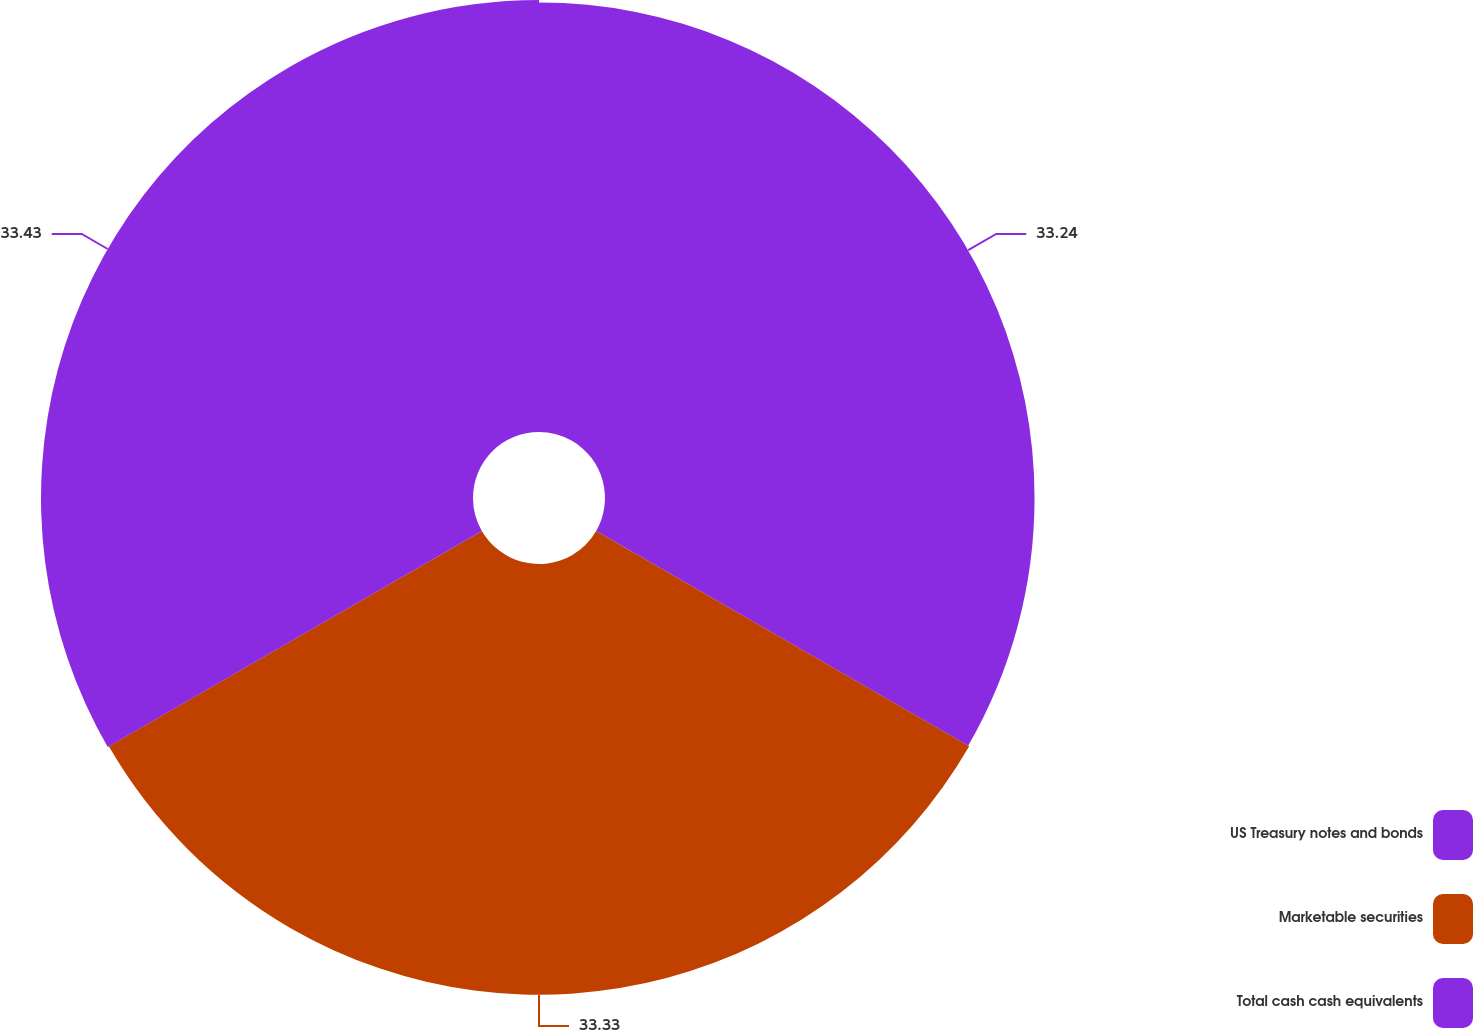<chart> <loc_0><loc_0><loc_500><loc_500><pie_chart><fcel>US Treasury notes and bonds<fcel>Marketable securities<fcel>Total cash cash equivalents<nl><fcel>33.24%<fcel>33.33%<fcel>33.43%<nl></chart> 